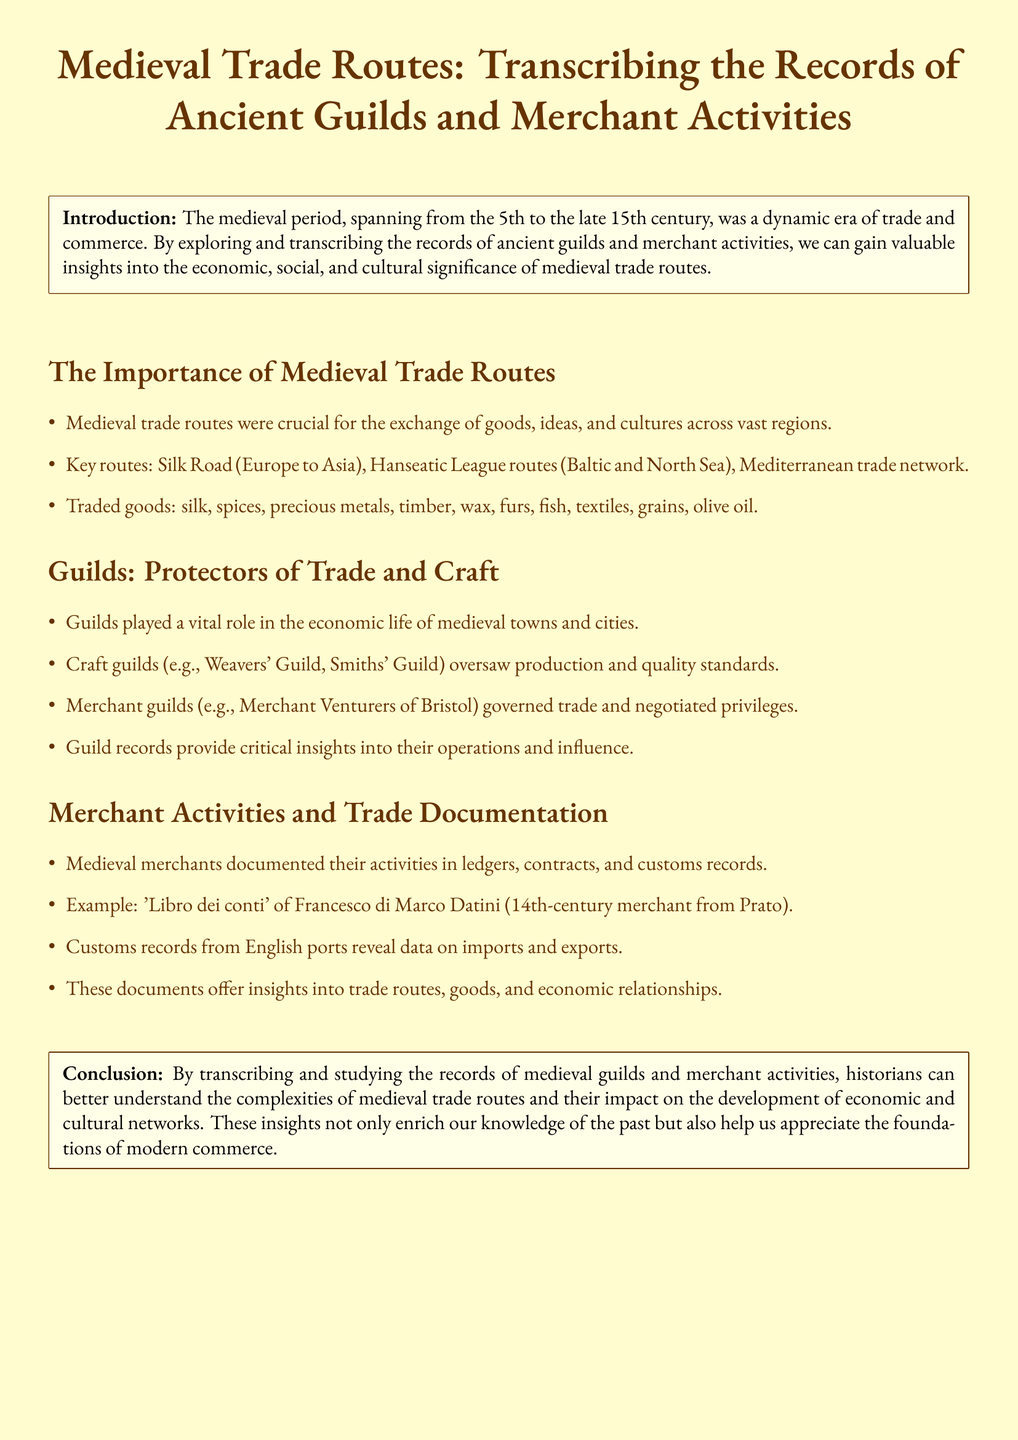What are the key trade routes mentioned? The document lists the Silk Road, Hanseatic League routes, and Mediterranean trade network as key routes.
Answer: Silk Road, Hanseatic League routes, Mediterranean trade network What goods were commonly traded during the medieval period? The document provides a list of goods including silk, spices, precious metals, timber, and more.
Answer: silk, spices, precious metals, timber, wax, furs, fish, textiles, grains, olive oil Who oversaw production and quality standards in medieval towns? The document states that craft guilds were responsible for overseeing production and quality standards.
Answer: Craft guilds Which merchant's records are specifically mentioned in the document? The 'Libro dei conti' of Francesco di Marco Datini is highlighted as an example of merchant records.
Answer: 'Libro dei conti' of Francesco di Marco Datini What impact did the study of guild records have according to the conclusion? The conclusion states that studying guild records helps historians understand the complexities of medieval trade routes.
Answer: Understand complexities of medieval trade routes How long did the medieval period span? The document defines the medieval period as lasting from the 5th to the late 15th century.
Answer: 5th to late 15th century What is a primary function of merchant guilds? The document explains that merchant guilds governed trade and negotiated privileges as a primary function.
Answer: Governed trade and negotiated privileges What is the significance of transcribing merchant activity records? The document suggests that transcribing these records enriches our knowledge of the past and modern commerce.
Answer: Enrich knowledge of the past and modern commerce 